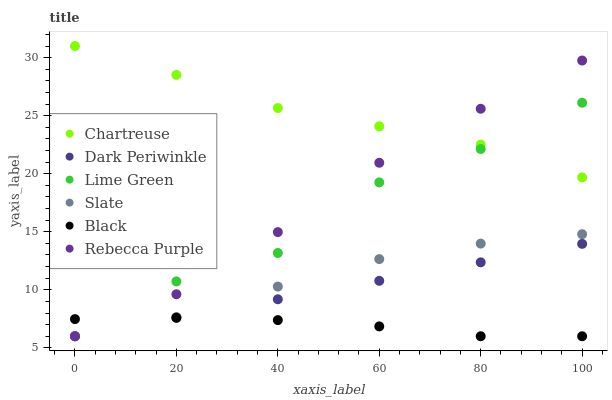Does Black have the minimum area under the curve?
Answer yes or no. Yes. Does Chartreuse have the maximum area under the curve?
Answer yes or no. Yes. Does Chartreuse have the minimum area under the curve?
Answer yes or no. No. Does Black have the maximum area under the curve?
Answer yes or no. No. Is Dark Periwinkle the smoothest?
Answer yes or no. Yes. Is Lime Green the roughest?
Answer yes or no. Yes. Is Chartreuse the smoothest?
Answer yes or no. No. Is Chartreuse the roughest?
Answer yes or no. No. Does Slate have the lowest value?
Answer yes or no. Yes. Does Chartreuse have the lowest value?
Answer yes or no. No. Does Chartreuse have the highest value?
Answer yes or no. Yes. Does Black have the highest value?
Answer yes or no. No. Is Black less than Chartreuse?
Answer yes or no. Yes. Is Chartreuse greater than Black?
Answer yes or no. Yes. Does Lime Green intersect Chartreuse?
Answer yes or no. Yes. Is Lime Green less than Chartreuse?
Answer yes or no. No. Is Lime Green greater than Chartreuse?
Answer yes or no. No. Does Black intersect Chartreuse?
Answer yes or no. No. 